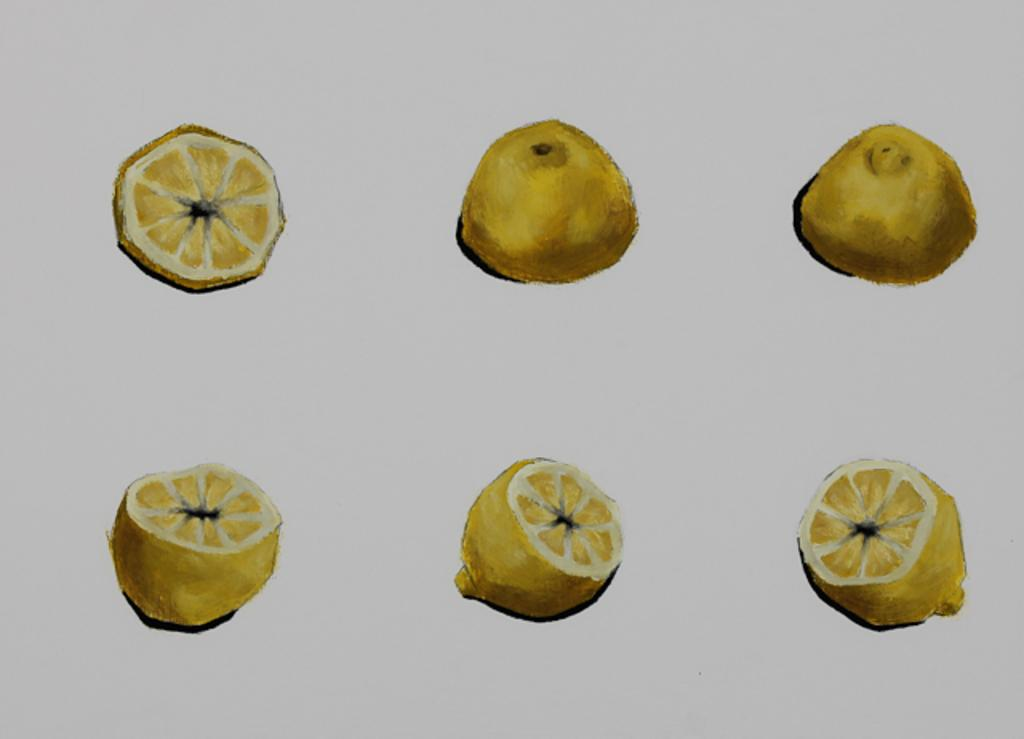How many pieces of a lemon can be seen in the image? There are six pieces of a lemon in the image. What is the color of the background in the image? The background of the image is ash in color. What type of artwork is depicted in the image? The image appears to be a painting. What type of coil is present in the image? There is no coil present in the image. What type of vegetable is depicted in the image? The image does not depict a vegetable; it features six pieces of a lemon. 